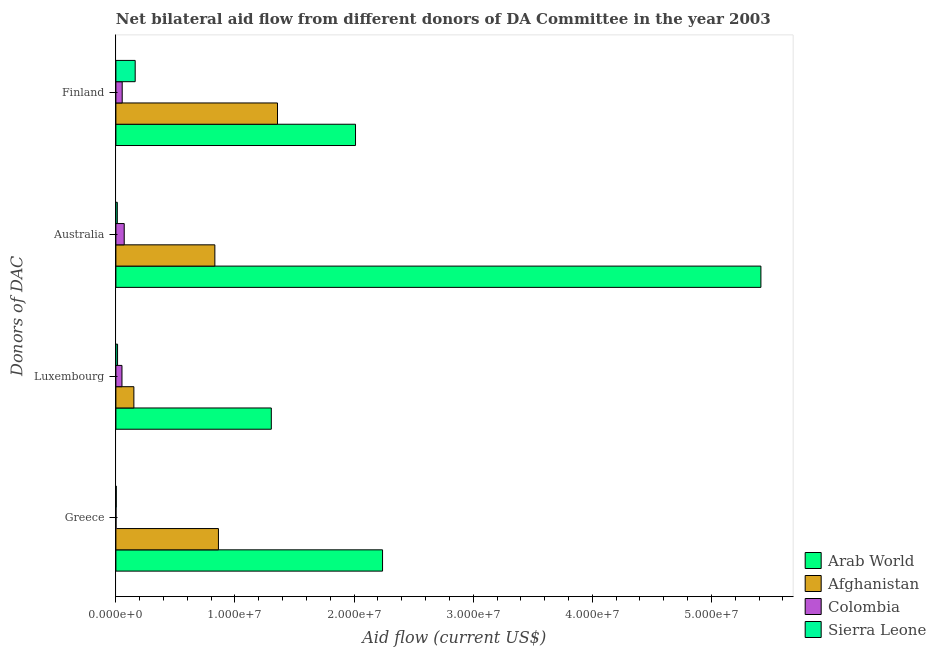How many different coloured bars are there?
Offer a very short reply. 4. Are the number of bars per tick equal to the number of legend labels?
Offer a terse response. Yes. How many bars are there on the 3rd tick from the top?
Make the answer very short. 4. How many bars are there on the 2nd tick from the bottom?
Make the answer very short. 4. What is the label of the 2nd group of bars from the top?
Keep it short and to the point. Australia. What is the amount of aid given by finland in Arab World?
Your answer should be compact. 2.01e+07. Across all countries, what is the maximum amount of aid given by australia?
Your response must be concise. 5.42e+07. Across all countries, what is the minimum amount of aid given by greece?
Provide a succinct answer. 10000. In which country was the amount of aid given by greece maximum?
Make the answer very short. Arab World. In which country was the amount of aid given by greece minimum?
Offer a terse response. Colombia. What is the total amount of aid given by australia in the graph?
Keep it short and to the point. 6.33e+07. What is the difference between the amount of aid given by australia in Afghanistan and that in Colombia?
Make the answer very short. 7.61e+06. What is the difference between the amount of aid given by finland in Arab World and the amount of aid given by australia in Sierra Leone?
Give a very brief answer. 2.00e+07. What is the average amount of aid given by greece per country?
Provide a short and direct response. 7.76e+06. What is the difference between the amount of aid given by greece and amount of aid given by australia in Colombia?
Ensure brevity in your answer.  -6.90e+05. What is the ratio of the amount of aid given by australia in Colombia to that in Sierra Leone?
Keep it short and to the point. 5.83. Is the amount of aid given by finland in Colombia less than that in Arab World?
Your response must be concise. Yes. Is the difference between the amount of aid given by luxembourg in Colombia and Sierra Leone greater than the difference between the amount of aid given by greece in Colombia and Sierra Leone?
Provide a short and direct response. Yes. What is the difference between the highest and the second highest amount of aid given by finland?
Provide a succinct answer. 6.55e+06. What is the difference between the highest and the lowest amount of aid given by australia?
Your answer should be compact. 5.40e+07. In how many countries, is the amount of aid given by australia greater than the average amount of aid given by australia taken over all countries?
Ensure brevity in your answer.  1. Is it the case that in every country, the sum of the amount of aid given by greece and amount of aid given by finland is greater than the sum of amount of aid given by australia and amount of aid given by luxembourg?
Make the answer very short. Yes. What does the 2nd bar from the top in Australia represents?
Keep it short and to the point. Colombia. What does the 4th bar from the bottom in Finland represents?
Keep it short and to the point. Sierra Leone. Is it the case that in every country, the sum of the amount of aid given by greece and amount of aid given by luxembourg is greater than the amount of aid given by australia?
Provide a succinct answer. No. How many countries are there in the graph?
Offer a very short reply. 4. What is the difference between two consecutive major ticks on the X-axis?
Keep it short and to the point. 1.00e+07. Are the values on the major ticks of X-axis written in scientific E-notation?
Ensure brevity in your answer.  Yes. Does the graph contain any zero values?
Keep it short and to the point. No. Where does the legend appear in the graph?
Offer a very short reply. Bottom right. How are the legend labels stacked?
Give a very brief answer. Vertical. What is the title of the graph?
Make the answer very short. Net bilateral aid flow from different donors of DA Committee in the year 2003. Does "Czech Republic" appear as one of the legend labels in the graph?
Provide a short and direct response. No. What is the label or title of the Y-axis?
Offer a terse response. Donors of DAC. What is the Aid flow (current US$) of Arab World in Greece?
Your response must be concise. 2.24e+07. What is the Aid flow (current US$) of Afghanistan in Greece?
Ensure brevity in your answer.  8.61e+06. What is the Aid flow (current US$) of Colombia in Greece?
Make the answer very short. 10000. What is the Aid flow (current US$) in Sierra Leone in Greece?
Ensure brevity in your answer.  3.00e+04. What is the Aid flow (current US$) in Arab World in Luxembourg?
Your response must be concise. 1.30e+07. What is the Aid flow (current US$) in Afghanistan in Luxembourg?
Ensure brevity in your answer.  1.51e+06. What is the Aid flow (current US$) in Colombia in Luxembourg?
Keep it short and to the point. 5.10e+05. What is the Aid flow (current US$) in Arab World in Australia?
Offer a very short reply. 5.42e+07. What is the Aid flow (current US$) of Afghanistan in Australia?
Ensure brevity in your answer.  8.31e+06. What is the Aid flow (current US$) in Colombia in Australia?
Make the answer very short. 7.00e+05. What is the Aid flow (current US$) of Sierra Leone in Australia?
Your answer should be compact. 1.20e+05. What is the Aid flow (current US$) of Arab World in Finland?
Keep it short and to the point. 2.01e+07. What is the Aid flow (current US$) in Afghanistan in Finland?
Provide a short and direct response. 1.36e+07. What is the Aid flow (current US$) of Colombia in Finland?
Make the answer very short. 5.30e+05. What is the Aid flow (current US$) in Sierra Leone in Finland?
Give a very brief answer. 1.62e+06. Across all Donors of DAC, what is the maximum Aid flow (current US$) of Arab World?
Make the answer very short. 5.42e+07. Across all Donors of DAC, what is the maximum Aid flow (current US$) in Afghanistan?
Provide a succinct answer. 1.36e+07. Across all Donors of DAC, what is the maximum Aid flow (current US$) of Colombia?
Your answer should be very brief. 7.00e+05. Across all Donors of DAC, what is the maximum Aid flow (current US$) of Sierra Leone?
Ensure brevity in your answer.  1.62e+06. Across all Donors of DAC, what is the minimum Aid flow (current US$) in Arab World?
Offer a terse response. 1.30e+07. Across all Donors of DAC, what is the minimum Aid flow (current US$) of Afghanistan?
Ensure brevity in your answer.  1.51e+06. What is the total Aid flow (current US$) of Arab World in the graph?
Your answer should be very brief. 1.10e+08. What is the total Aid flow (current US$) in Afghanistan in the graph?
Provide a short and direct response. 3.20e+07. What is the total Aid flow (current US$) of Colombia in the graph?
Provide a short and direct response. 1.75e+06. What is the total Aid flow (current US$) in Sierra Leone in the graph?
Provide a short and direct response. 1.91e+06. What is the difference between the Aid flow (current US$) of Arab World in Greece and that in Luxembourg?
Provide a short and direct response. 9.34e+06. What is the difference between the Aid flow (current US$) of Afghanistan in Greece and that in Luxembourg?
Ensure brevity in your answer.  7.10e+06. What is the difference between the Aid flow (current US$) of Colombia in Greece and that in Luxembourg?
Give a very brief answer. -5.00e+05. What is the difference between the Aid flow (current US$) in Arab World in Greece and that in Australia?
Keep it short and to the point. -3.18e+07. What is the difference between the Aid flow (current US$) in Afghanistan in Greece and that in Australia?
Ensure brevity in your answer.  3.00e+05. What is the difference between the Aid flow (current US$) in Colombia in Greece and that in Australia?
Your answer should be very brief. -6.90e+05. What is the difference between the Aid flow (current US$) of Sierra Leone in Greece and that in Australia?
Your answer should be very brief. -9.00e+04. What is the difference between the Aid flow (current US$) in Arab World in Greece and that in Finland?
Your answer should be compact. 2.27e+06. What is the difference between the Aid flow (current US$) in Afghanistan in Greece and that in Finland?
Make the answer very short. -4.96e+06. What is the difference between the Aid flow (current US$) in Colombia in Greece and that in Finland?
Ensure brevity in your answer.  -5.20e+05. What is the difference between the Aid flow (current US$) of Sierra Leone in Greece and that in Finland?
Give a very brief answer. -1.59e+06. What is the difference between the Aid flow (current US$) of Arab World in Luxembourg and that in Australia?
Your answer should be compact. -4.11e+07. What is the difference between the Aid flow (current US$) of Afghanistan in Luxembourg and that in Australia?
Your answer should be compact. -6.80e+06. What is the difference between the Aid flow (current US$) in Colombia in Luxembourg and that in Australia?
Provide a succinct answer. -1.90e+05. What is the difference between the Aid flow (current US$) of Sierra Leone in Luxembourg and that in Australia?
Your response must be concise. 2.00e+04. What is the difference between the Aid flow (current US$) of Arab World in Luxembourg and that in Finland?
Ensure brevity in your answer.  -7.07e+06. What is the difference between the Aid flow (current US$) of Afghanistan in Luxembourg and that in Finland?
Your answer should be very brief. -1.21e+07. What is the difference between the Aid flow (current US$) of Colombia in Luxembourg and that in Finland?
Offer a terse response. -2.00e+04. What is the difference between the Aid flow (current US$) in Sierra Leone in Luxembourg and that in Finland?
Ensure brevity in your answer.  -1.48e+06. What is the difference between the Aid flow (current US$) in Arab World in Australia and that in Finland?
Offer a very short reply. 3.40e+07. What is the difference between the Aid flow (current US$) in Afghanistan in Australia and that in Finland?
Give a very brief answer. -5.26e+06. What is the difference between the Aid flow (current US$) in Sierra Leone in Australia and that in Finland?
Make the answer very short. -1.50e+06. What is the difference between the Aid flow (current US$) in Arab World in Greece and the Aid flow (current US$) in Afghanistan in Luxembourg?
Offer a terse response. 2.09e+07. What is the difference between the Aid flow (current US$) in Arab World in Greece and the Aid flow (current US$) in Colombia in Luxembourg?
Give a very brief answer. 2.19e+07. What is the difference between the Aid flow (current US$) in Arab World in Greece and the Aid flow (current US$) in Sierra Leone in Luxembourg?
Offer a very short reply. 2.22e+07. What is the difference between the Aid flow (current US$) in Afghanistan in Greece and the Aid flow (current US$) in Colombia in Luxembourg?
Keep it short and to the point. 8.10e+06. What is the difference between the Aid flow (current US$) of Afghanistan in Greece and the Aid flow (current US$) of Sierra Leone in Luxembourg?
Keep it short and to the point. 8.47e+06. What is the difference between the Aid flow (current US$) in Arab World in Greece and the Aid flow (current US$) in Afghanistan in Australia?
Your response must be concise. 1.41e+07. What is the difference between the Aid flow (current US$) in Arab World in Greece and the Aid flow (current US$) in Colombia in Australia?
Provide a short and direct response. 2.17e+07. What is the difference between the Aid flow (current US$) in Arab World in Greece and the Aid flow (current US$) in Sierra Leone in Australia?
Ensure brevity in your answer.  2.23e+07. What is the difference between the Aid flow (current US$) of Afghanistan in Greece and the Aid flow (current US$) of Colombia in Australia?
Offer a very short reply. 7.91e+06. What is the difference between the Aid flow (current US$) in Afghanistan in Greece and the Aid flow (current US$) in Sierra Leone in Australia?
Offer a terse response. 8.49e+06. What is the difference between the Aid flow (current US$) in Colombia in Greece and the Aid flow (current US$) in Sierra Leone in Australia?
Offer a terse response. -1.10e+05. What is the difference between the Aid flow (current US$) in Arab World in Greece and the Aid flow (current US$) in Afghanistan in Finland?
Keep it short and to the point. 8.82e+06. What is the difference between the Aid flow (current US$) in Arab World in Greece and the Aid flow (current US$) in Colombia in Finland?
Offer a terse response. 2.19e+07. What is the difference between the Aid flow (current US$) in Arab World in Greece and the Aid flow (current US$) in Sierra Leone in Finland?
Your answer should be compact. 2.08e+07. What is the difference between the Aid flow (current US$) in Afghanistan in Greece and the Aid flow (current US$) in Colombia in Finland?
Make the answer very short. 8.08e+06. What is the difference between the Aid flow (current US$) of Afghanistan in Greece and the Aid flow (current US$) of Sierra Leone in Finland?
Keep it short and to the point. 6.99e+06. What is the difference between the Aid flow (current US$) in Colombia in Greece and the Aid flow (current US$) in Sierra Leone in Finland?
Ensure brevity in your answer.  -1.61e+06. What is the difference between the Aid flow (current US$) in Arab World in Luxembourg and the Aid flow (current US$) in Afghanistan in Australia?
Make the answer very short. 4.74e+06. What is the difference between the Aid flow (current US$) of Arab World in Luxembourg and the Aid flow (current US$) of Colombia in Australia?
Offer a terse response. 1.24e+07. What is the difference between the Aid flow (current US$) in Arab World in Luxembourg and the Aid flow (current US$) in Sierra Leone in Australia?
Your answer should be compact. 1.29e+07. What is the difference between the Aid flow (current US$) of Afghanistan in Luxembourg and the Aid flow (current US$) of Colombia in Australia?
Keep it short and to the point. 8.10e+05. What is the difference between the Aid flow (current US$) of Afghanistan in Luxembourg and the Aid flow (current US$) of Sierra Leone in Australia?
Offer a very short reply. 1.39e+06. What is the difference between the Aid flow (current US$) in Colombia in Luxembourg and the Aid flow (current US$) in Sierra Leone in Australia?
Offer a very short reply. 3.90e+05. What is the difference between the Aid flow (current US$) in Arab World in Luxembourg and the Aid flow (current US$) in Afghanistan in Finland?
Your answer should be compact. -5.20e+05. What is the difference between the Aid flow (current US$) of Arab World in Luxembourg and the Aid flow (current US$) of Colombia in Finland?
Provide a succinct answer. 1.25e+07. What is the difference between the Aid flow (current US$) in Arab World in Luxembourg and the Aid flow (current US$) in Sierra Leone in Finland?
Make the answer very short. 1.14e+07. What is the difference between the Aid flow (current US$) in Afghanistan in Luxembourg and the Aid flow (current US$) in Colombia in Finland?
Offer a very short reply. 9.80e+05. What is the difference between the Aid flow (current US$) in Colombia in Luxembourg and the Aid flow (current US$) in Sierra Leone in Finland?
Offer a very short reply. -1.11e+06. What is the difference between the Aid flow (current US$) of Arab World in Australia and the Aid flow (current US$) of Afghanistan in Finland?
Give a very brief answer. 4.06e+07. What is the difference between the Aid flow (current US$) of Arab World in Australia and the Aid flow (current US$) of Colombia in Finland?
Your response must be concise. 5.36e+07. What is the difference between the Aid flow (current US$) in Arab World in Australia and the Aid flow (current US$) in Sierra Leone in Finland?
Your answer should be compact. 5.25e+07. What is the difference between the Aid flow (current US$) of Afghanistan in Australia and the Aid flow (current US$) of Colombia in Finland?
Keep it short and to the point. 7.78e+06. What is the difference between the Aid flow (current US$) in Afghanistan in Australia and the Aid flow (current US$) in Sierra Leone in Finland?
Give a very brief answer. 6.69e+06. What is the difference between the Aid flow (current US$) of Colombia in Australia and the Aid flow (current US$) of Sierra Leone in Finland?
Your answer should be very brief. -9.20e+05. What is the average Aid flow (current US$) in Arab World per Donors of DAC?
Provide a succinct answer. 2.74e+07. What is the average Aid flow (current US$) of Afghanistan per Donors of DAC?
Your answer should be very brief. 8.00e+06. What is the average Aid flow (current US$) in Colombia per Donors of DAC?
Ensure brevity in your answer.  4.38e+05. What is the average Aid flow (current US$) in Sierra Leone per Donors of DAC?
Give a very brief answer. 4.78e+05. What is the difference between the Aid flow (current US$) of Arab World and Aid flow (current US$) of Afghanistan in Greece?
Keep it short and to the point. 1.38e+07. What is the difference between the Aid flow (current US$) in Arab World and Aid flow (current US$) in Colombia in Greece?
Provide a short and direct response. 2.24e+07. What is the difference between the Aid flow (current US$) of Arab World and Aid flow (current US$) of Sierra Leone in Greece?
Provide a short and direct response. 2.24e+07. What is the difference between the Aid flow (current US$) in Afghanistan and Aid flow (current US$) in Colombia in Greece?
Keep it short and to the point. 8.60e+06. What is the difference between the Aid flow (current US$) of Afghanistan and Aid flow (current US$) of Sierra Leone in Greece?
Keep it short and to the point. 8.58e+06. What is the difference between the Aid flow (current US$) in Arab World and Aid flow (current US$) in Afghanistan in Luxembourg?
Keep it short and to the point. 1.15e+07. What is the difference between the Aid flow (current US$) of Arab World and Aid flow (current US$) of Colombia in Luxembourg?
Ensure brevity in your answer.  1.25e+07. What is the difference between the Aid flow (current US$) of Arab World and Aid flow (current US$) of Sierra Leone in Luxembourg?
Provide a short and direct response. 1.29e+07. What is the difference between the Aid flow (current US$) in Afghanistan and Aid flow (current US$) in Sierra Leone in Luxembourg?
Keep it short and to the point. 1.37e+06. What is the difference between the Aid flow (current US$) of Arab World and Aid flow (current US$) of Afghanistan in Australia?
Keep it short and to the point. 4.58e+07. What is the difference between the Aid flow (current US$) in Arab World and Aid flow (current US$) in Colombia in Australia?
Ensure brevity in your answer.  5.35e+07. What is the difference between the Aid flow (current US$) of Arab World and Aid flow (current US$) of Sierra Leone in Australia?
Ensure brevity in your answer.  5.40e+07. What is the difference between the Aid flow (current US$) of Afghanistan and Aid flow (current US$) of Colombia in Australia?
Provide a succinct answer. 7.61e+06. What is the difference between the Aid flow (current US$) in Afghanistan and Aid flow (current US$) in Sierra Leone in Australia?
Provide a short and direct response. 8.19e+06. What is the difference between the Aid flow (current US$) in Colombia and Aid flow (current US$) in Sierra Leone in Australia?
Provide a succinct answer. 5.80e+05. What is the difference between the Aid flow (current US$) in Arab World and Aid flow (current US$) in Afghanistan in Finland?
Your response must be concise. 6.55e+06. What is the difference between the Aid flow (current US$) of Arab World and Aid flow (current US$) of Colombia in Finland?
Provide a short and direct response. 1.96e+07. What is the difference between the Aid flow (current US$) in Arab World and Aid flow (current US$) in Sierra Leone in Finland?
Give a very brief answer. 1.85e+07. What is the difference between the Aid flow (current US$) of Afghanistan and Aid flow (current US$) of Colombia in Finland?
Your answer should be compact. 1.30e+07. What is the difference between the Aid flow (current US$) of Afghanistan and Aid flow (current US$) of Sierra Leone in Finland?
Keep it short and to the point. 1.20e+07. What is the difference between the Aid flow (current US$) in Colombia and Aid flow (current US$) in Sierra Leone in Finland?
Your answer should be very brief. -1.09e+06. What is the ratio of the Aid flow (current US$) of Arab World in Greece to that in Luxembourg?
Offer a very short reply. 1.72. What is the ratio of the Aid flow (current US$) in Afghanistan in Greece to that in Luxembourg?
Your answer should be compact. 5.7. What is the ratio of the Aid flow (current US$) in Colombia in Greece to that in Luxembourg?
Keep it short and to the point. 0.02. What is the ratio of the Aid flow (current US$) of Sierra Leone in Greece to that in Luxembourg?
Offer a terse response. 0.21. What is the ratio of the Aid flow (current US$) in Arab World in Greece to that in Australia?
Provide a succinct answer. 0.41. What is the ratio of the Aid flow (current US$) of Afghanistan in Greece to that in Australia?
Give a very brief answer. 1.04. What is the ratio of the Aid flow (current US$) in Colombia in Greece to that in Australia?
Your response must be concise. 0.01. What is the ratio of the Aid flow (current US$) in Sierra Leone in Greece to that in Australia?
Provide a succinct answer. 0.25. What is the ratio of the Aid flow (current US$) of Arab World in Greece to that in Finland?
Make the answer very short. 1.11. What is the ratio of the Aid flow (current US$) in Afghanistan in Greece to that in Finland?
Offer a terse response. 0.63. What is the ratio of the Aid flow (current US$) of Colombia in Greece to that in Finland?
Your answer should be very brief. 0.02. What is the ratio of the Aid flow (current US$) of Sierra Leone in Greece to that in Finland?
Your answer should be compact. 0.02. What is the ratio of the Aid flow (current US$) of Arab World in Luxembourg to that in Australia?
Offer a very short reply. 0.24. What is the ratio of the Aid flow (current US$) of Afghanistan in Luxembourg to that in Australia?
Offer a very short reply. 0.18. What is the ratio of the Aid flow (current US$) in Colombia in Luxembourg to that in Australia?
Provide a short and direct response. 0.73. What is the ratio of the Aid flow (current US$) in Sierra Leone in Luxembourg to that in Australia?
Your answer should be very brief. 1.17. What is the ratio of the Aid flow (current US$) in Arab World in Luxembourg to that in Finland?
Offer a terse response. 0.65. What is the ratio of the Aid flow (current US$) in Afghanistan in Luxembourg to that in Finland?
Your response must be concise. 0.11. What is the ratio of the Aid flow (current US$) of Colombia in Luxembourg to that in Finland?
Keep it short and to the point. 0.96. What is the ratio of the Aid flow (current US$) of Sierra Leone in Luxembourg to that in Finland?
Your answer should be very brief. 0.09. What is the ratio of the Aid flow (current US$) in Arab World in Australia to that in Finland?
Offer a very short reply. 2.69. What is the ratio of the Aid flow (current US$) in Afghanistan in Australia to that in Finland?
Your response must be concise. 0.61. What is the ratio of the Aid flow (current US$) of Colombia in Australia to that in Finland?
Your answer should be compact. 1.32. What is the ratio of the Aid flow (current US$) of Sierra Leone in Australia to that in Finland?
Offer a terse response. 0.07. What is the difference between the highest and the second highest Aid flow (current US$) of Arab World?
Provide a short and direct response. 3.18e+07. What is the difference between the highest and the second highest Aid flow (current US$) of Afghanistan?
Your response must be concise. 4.96e+06. What is the difference between the highest and the second highest Aid flow (current US$) of Colombia?
Provide a short and direct response. 1.70e+05. What is the difference between the highest and the second highest Aid flow (current US$) in Sierra Leone?
Provide a short and direct response. 1.48e+06. What is the difference between the highest and the lowest Aid flow (current US$) in Arab World?
Offer a very short reply. 4.11e+07. What is the difference between the highest and the lowest Aid flow (current US$) of Afghanistan?
Provide a succinct answer. 1.21e+07. What is the difference between the highest and the lowest Aid flow (current US$) in Colombia?
Your answer should be very brief. 6.90e+05. What is the difference between the highest and the lowest Aid flow (current US$) in Sierra Leone?
Your answer should be very brief. 1.59e+06. 